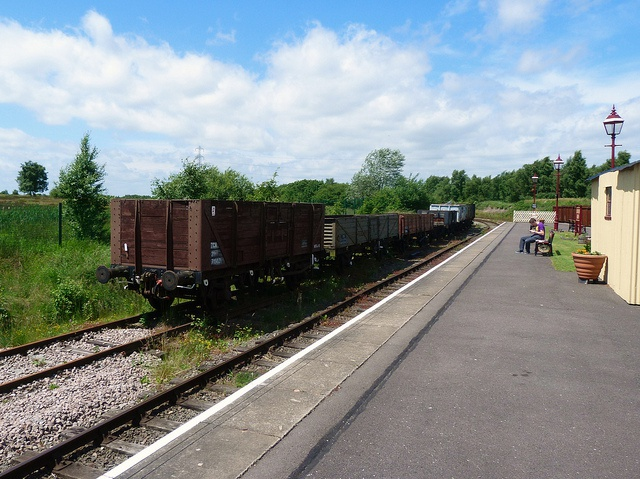Describe the objects in this image and their specific colors. I can see train in lightblue, black, maroon, gray, and darkgreen tones, potted plant in lightblue, maroon, brown, olive, and tan tones, people in lightblue, gray, black, darkgray, and navy tones, bench in lightblue, black, gray, maroon, and darkgreen tones, and bench in lightblue, maroon, black, gray, and darkgray tones in this image. 